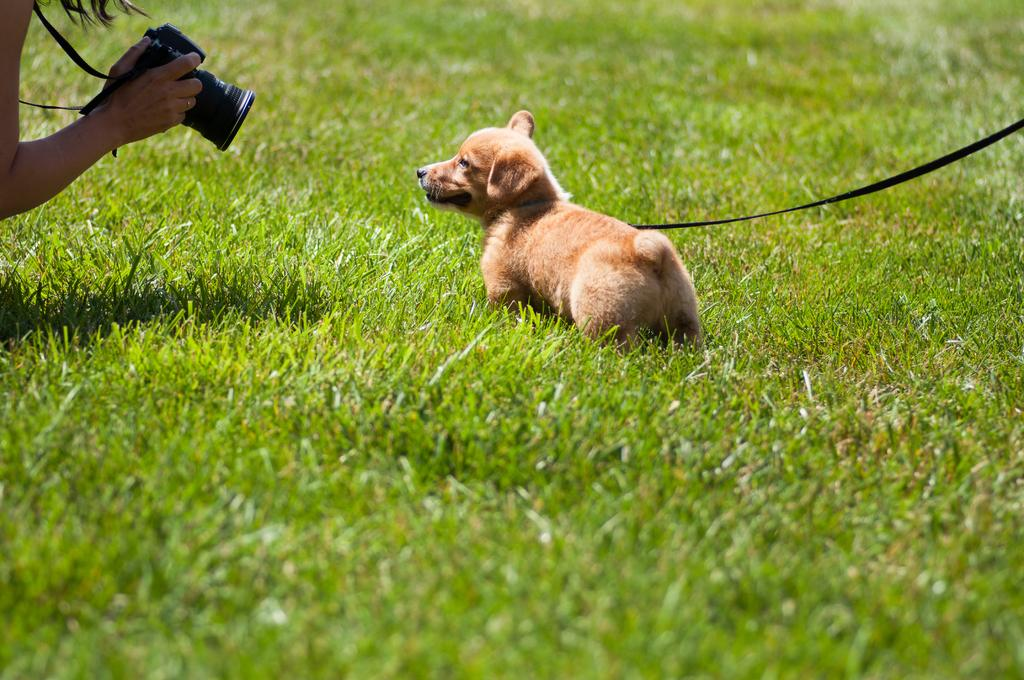What is the main subject in the center of the image? There is a dog in the center of the image. What type of terrain is visible at the bottom of the image? There is grass visible at the bottom of the image. What is the person on the right side of the image doing? There is a person holding a camera on the right side of the image. How many lizards can be seen crawling on the dog in the image? There are no lizards visible in the image; the main subject is a dog. 